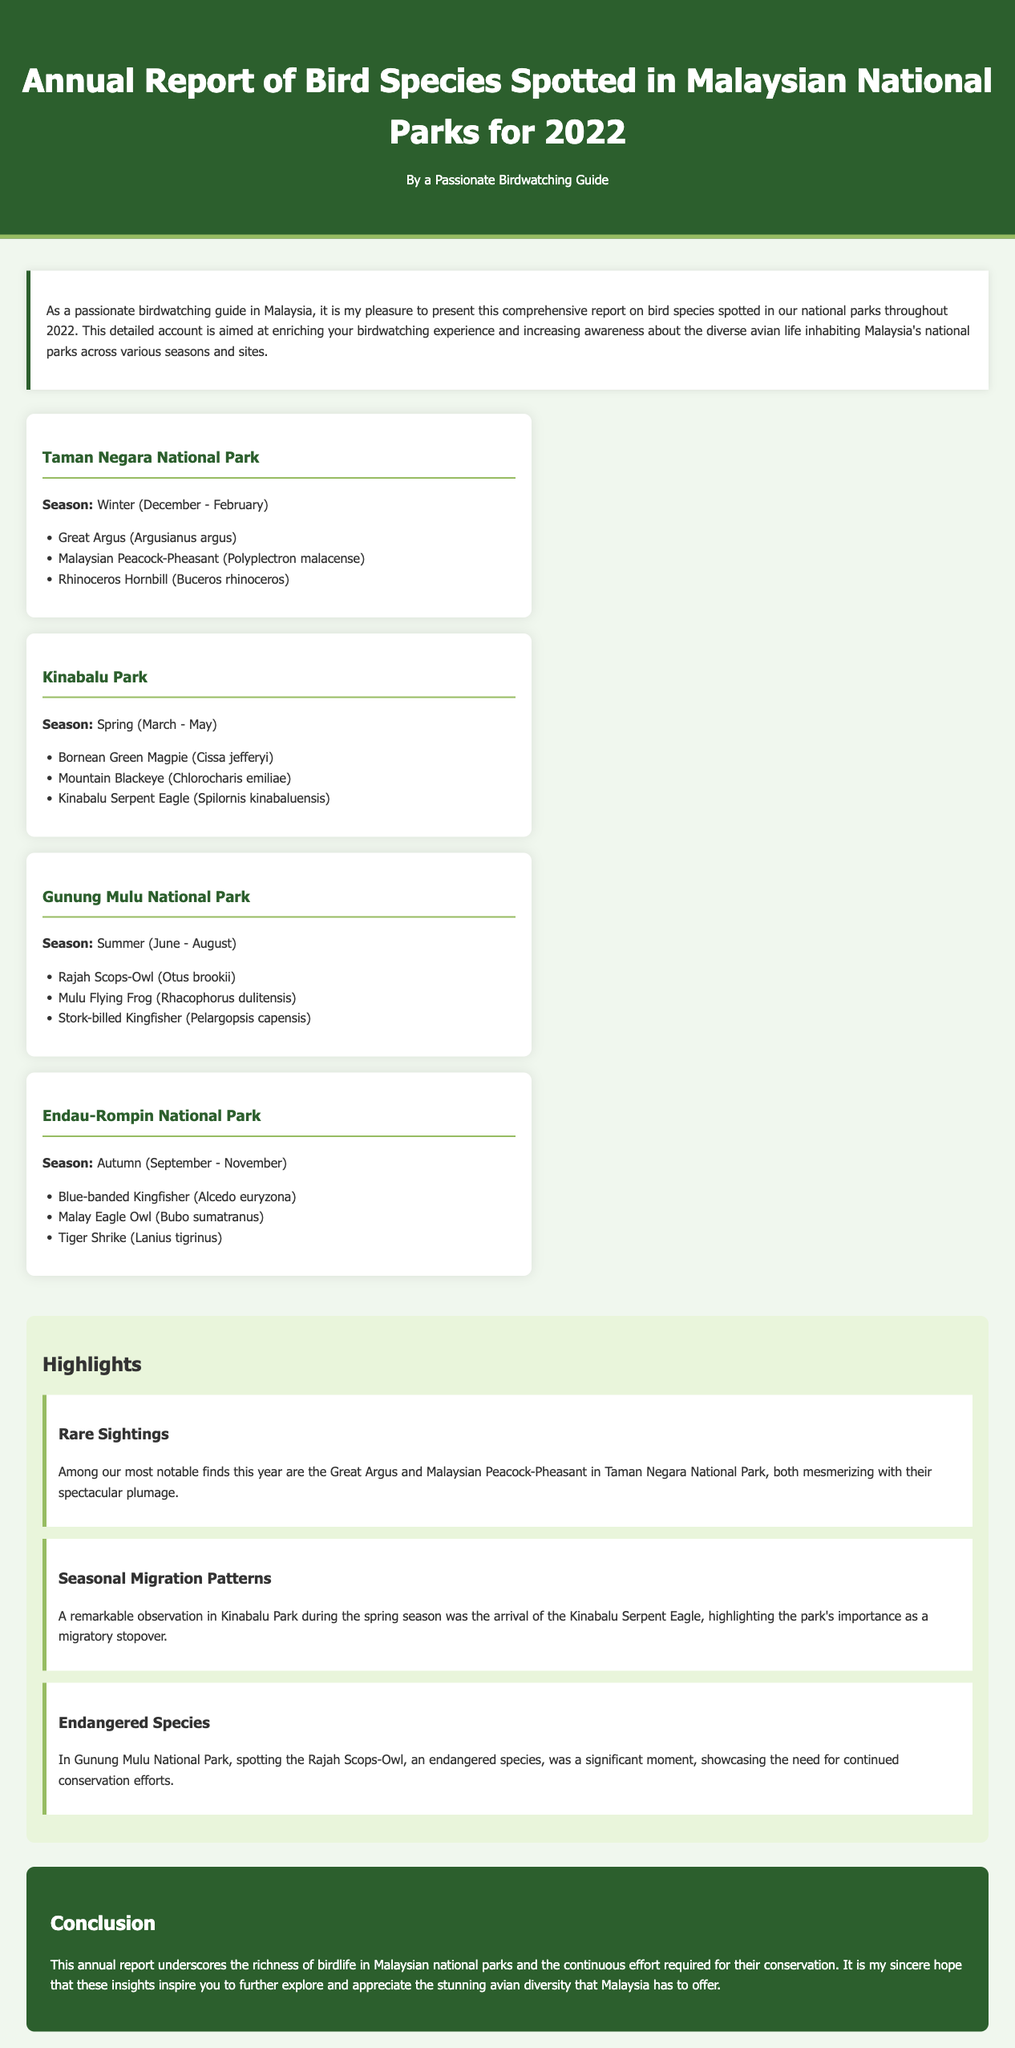What is the title of the report? The title of the report is prominently displayed in the header of the document.
Answer: Annual Report of Bird Species Spotted in Malaysian National Parks for 2022 How many species were spotted in Taman Negara National Park during winter? The document lists three bird species spotted in Taman Negara during the winter season.
Answer: 3 Which national park has its highlights focused on the Rajah Scops-Owl? The document mentions the Rajah Scops-Owl in the context of Gunung Mulu National Park under the highlights section.
Answer: Gunung Mulu National Park What season does Kinabalu Park represent? The document specifies the season associated with Kinabalu Park in its description.
Answer: Spring What is the primary focus of the annual report? The key focus is outlined in the introductory paragraph, detailing the comprehensiveness regarding bird species.
Answer: Bird species spotted in national parks When does the autumn season occur in Endau-Rompin National Park? The document states the months that constitute the autumn season for Endau-Rompin National Park.
Answer: September - November What is stated about endangered species in the highlights section? The highlights discuss the significance of spotting endangered species during observations.
Answer: Continuation of conservation efforts Which bird species has the scientific name Argusianus argus? The document lists this species under Taman Negara National Park during winter.
Answer: Great Argus 